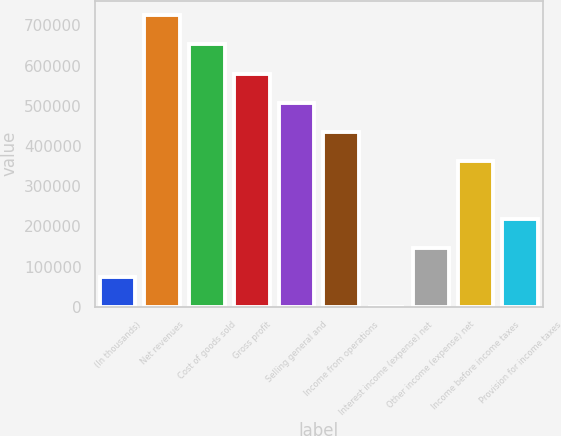<chart> <loc_0><loc_0><loc_500><loc_500><bar_chart><fcel>(In thousands)<fcel>Net revenues<fcel>Cost of goods sold<fcel>Gross profit<fcel>Selling general and<fcel>Income from operations<fcel>Interest income (expense) net<fcel>Other income (expense) net<fcel>Income before income taxes<fcel>Provision for income taxes<nl><fcel>73289.4<fcel>725244<fcel>652805<fcel>580365<fcel>507926<fcel>435486<fcel>850<fcel>145729<fcel>363047<fcel>218168<nl></chart> 